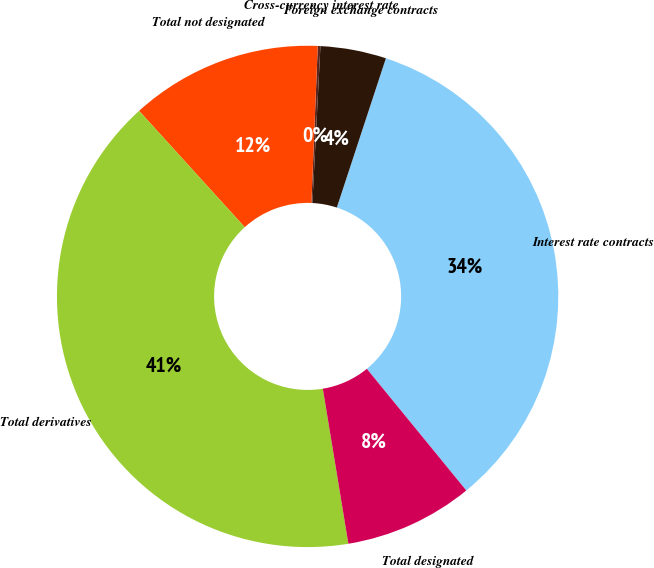Convert chart to OTSL. <chart><loc_0><loc_0><loc_500><loc_500><pie_chart><fcel>Interest rate contracts<fcel>Foreign exchange contracts<fcel>Cross-currency interest rate<fcel>Total not designated<fcel>Total derivatives<fcel>Total designated<nl><fcel>34.04%<fcel>4.24%<fcel>0.17%<fcel>12.38%<fcel>40.87%<fcel>8.31%<nl></chart> 